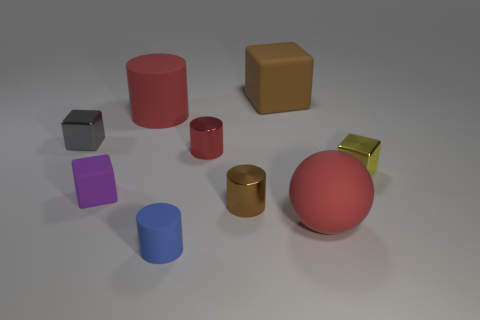There is a small thing that is the same color as the large cube; what is it made of?
Provide a short and direct response. Metal. There is a big cylinder; is it the same color as the rubber block right of the blue object?
Offer a very short reply. No. The big cube has what color?
Your answer should be very brief. Brown. How many objects are small gray matte balls or large red rubber balls?
Your answer should be very brief. 1. There is a yellow object that is the same size as the purple thing; what material is it?
Provide a succinct answer. Metal. There is a metal cube that is in front of the gray block; how big is it?
Make the answer very short. Small. What is the large red cylinder made of?
Your answer should be compact. Rubber. What number of objects are either small metal things that are behind the tiny brown cylinder or matte cubes that are to the right of the big red matte cylinder?
Your answer should be very brief. 4. How many other things are there of the same color as the large cylinder?
Provide a succinct answer. 2. Is the shape of the tiny gray object the same as the big red object in front of the small gray metal block?
Make the answer very short. No. 